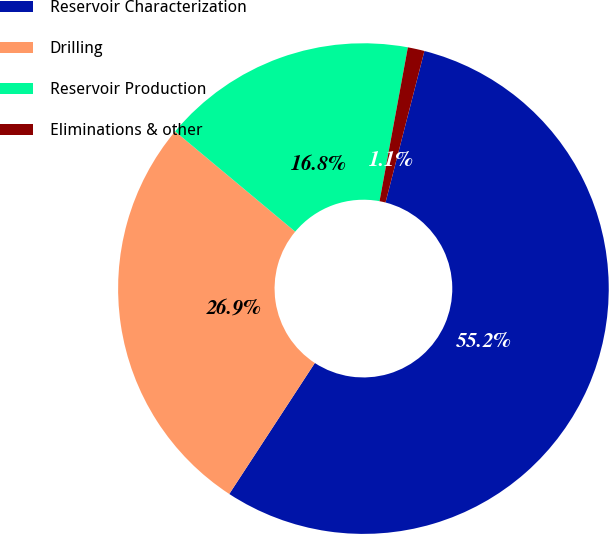Convert chart. <chart><loc_0><loc_0><loc_500><loc_500><pie_chart><fcel>Reservoir Characterization<fcel>Drilling<fcel>Reservoir Production<fcel>Eliminations & other<nl><fcel>55.21%<fcel>26.86%<fcel>16.83%<fcel>1.1%<nl></chart> 